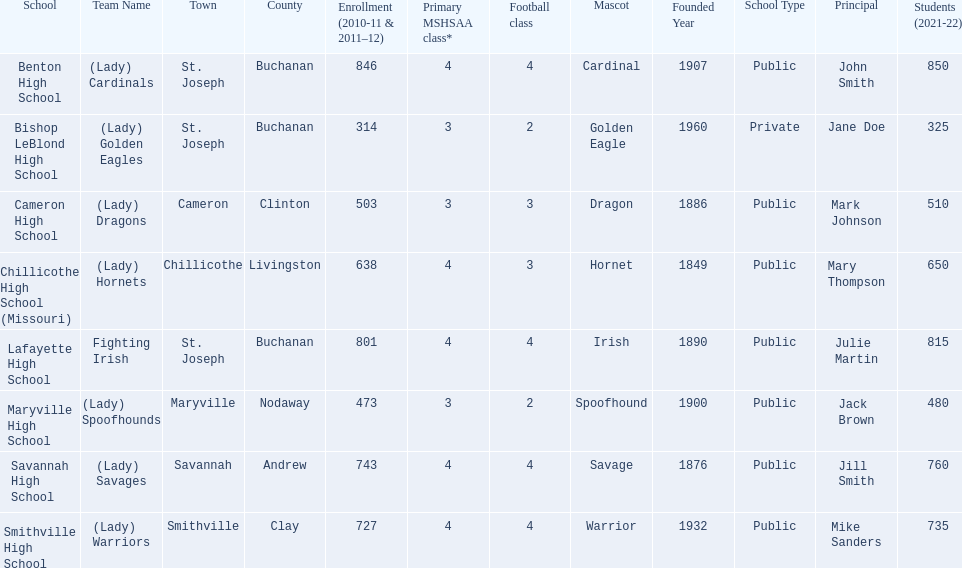How many are enrolled at each school? Benton High School, 846, Bishop LeBlond High School, 314, Cameron High School, 503, Chillicothe High School (Missouri), 638, Lafayette High School, 801, Maryville High School, 473, Savannah High School, 743, Smithville High School, 727. Which school has at only three football classes? Cameron High School, 3, Chillicothe High School (Missouri), 3. Which school has 638 enrolled and 3 football classes? Chillicothe High School (Missouri). 